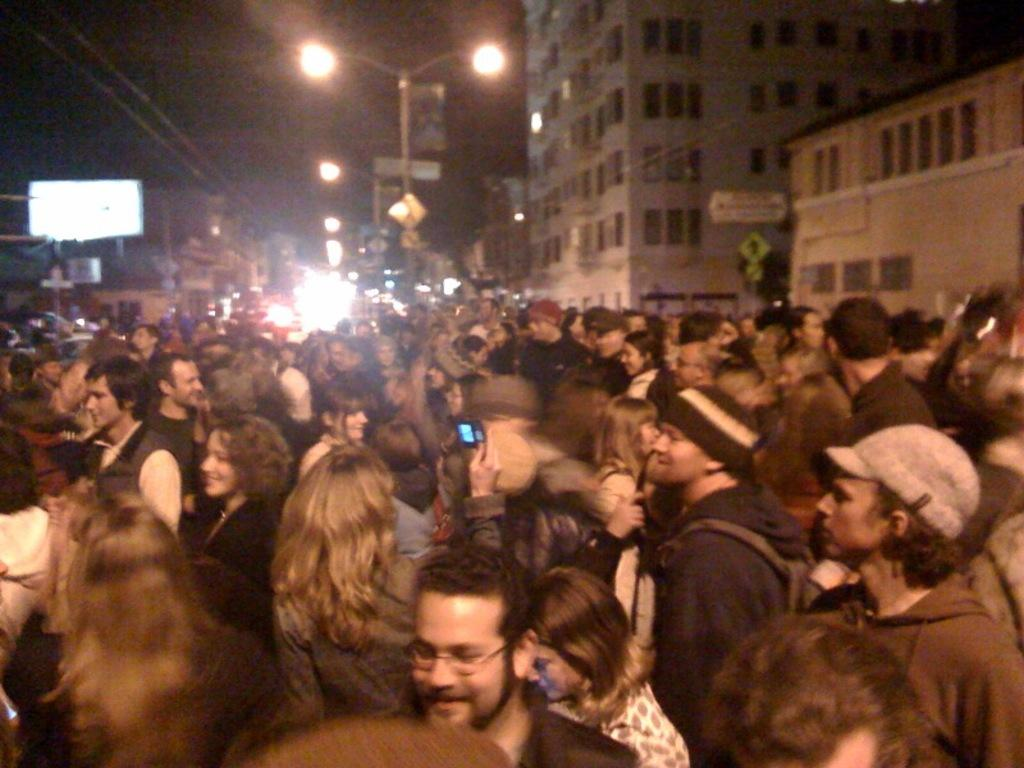What are the people in the image doing? The people in the image are standing on the road. What can be seen in the background of the image? Street lights, wires, and buildings are present in the background of the image. What type of creature is using the brush to paint the buildings in the image? There is no creature or brush present in the image; the buildings are not being painted. 